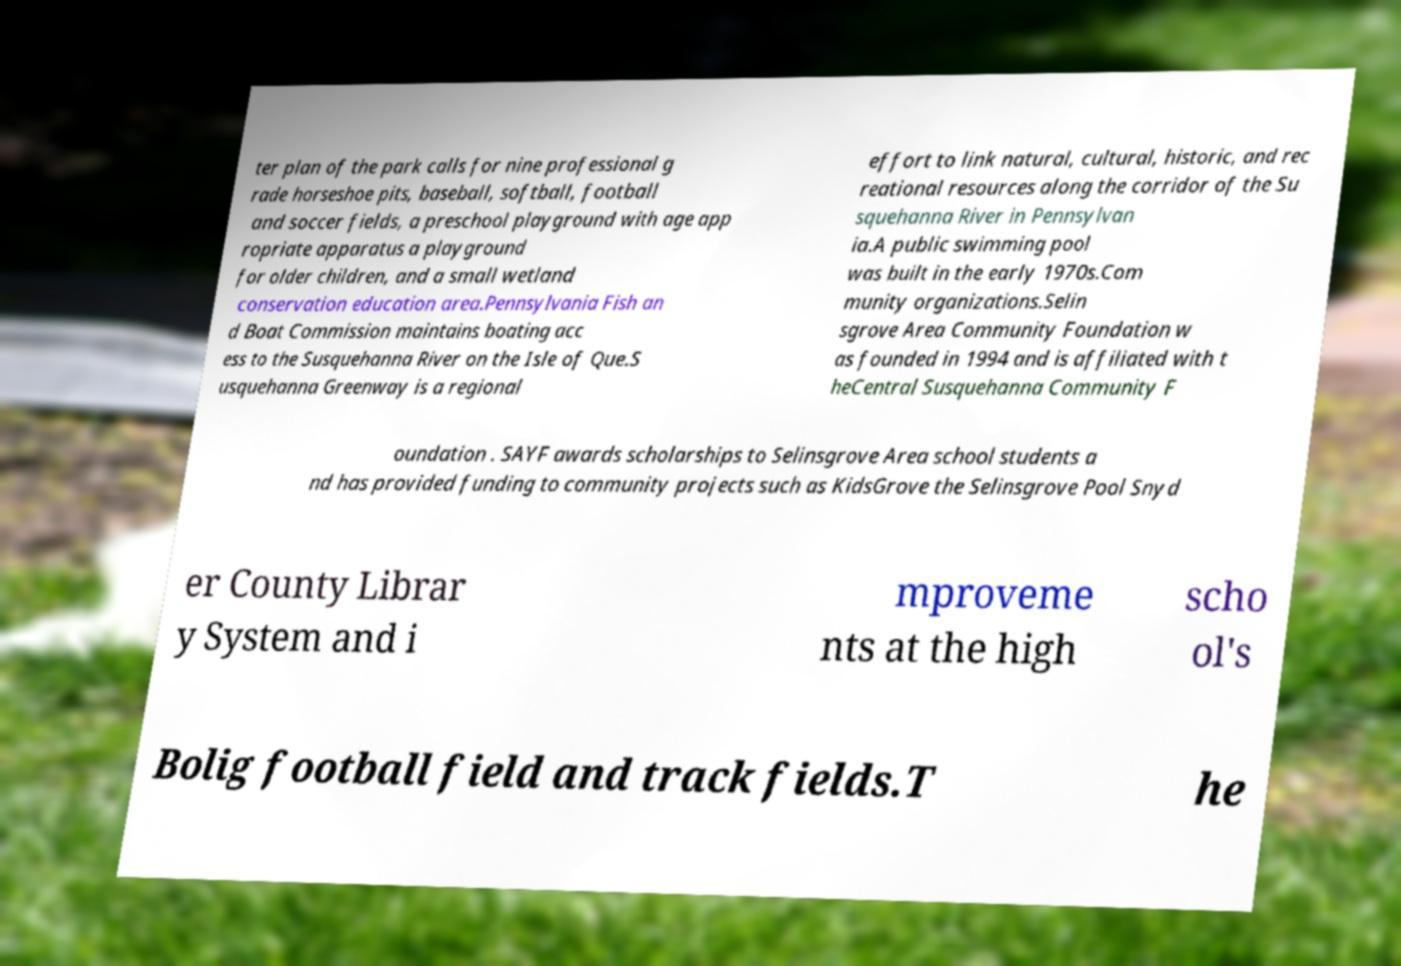I need the written content from this picture converted into text. Can you do that? ter plan of the park calls for nine professional g rade horseshoe pits, baseball, softball, football and soccer fields, a preschool playground with age app ropriate apparatus a playground for older children, and a small wetland conservation education area.Pennsylvania Fish an d Boat Commission maintains boating acc ess to the Susquehanna River on the Isle of Que.S usquehanna Greenway is a regional effort to link natural, cultural, historic, and rec reational resources along the corridor of the Su squehanna River in Pennsylvan ia.A public swimming pool was built in the early 1970s.Com munity organizations.Selin sgrove Area Community Foundation w as founded in 1994 and is affiliated with t heCentral Susquehanna Community F oundation . SAYF awards scholarships to Selinsgrove Area school students a nd has provided funding to community projects such as KidsGrove the Selinsgrove Pool Snyd er County Librar y System and i mproveme nts at the high scho ol's Bolig football field and track fields.T he 